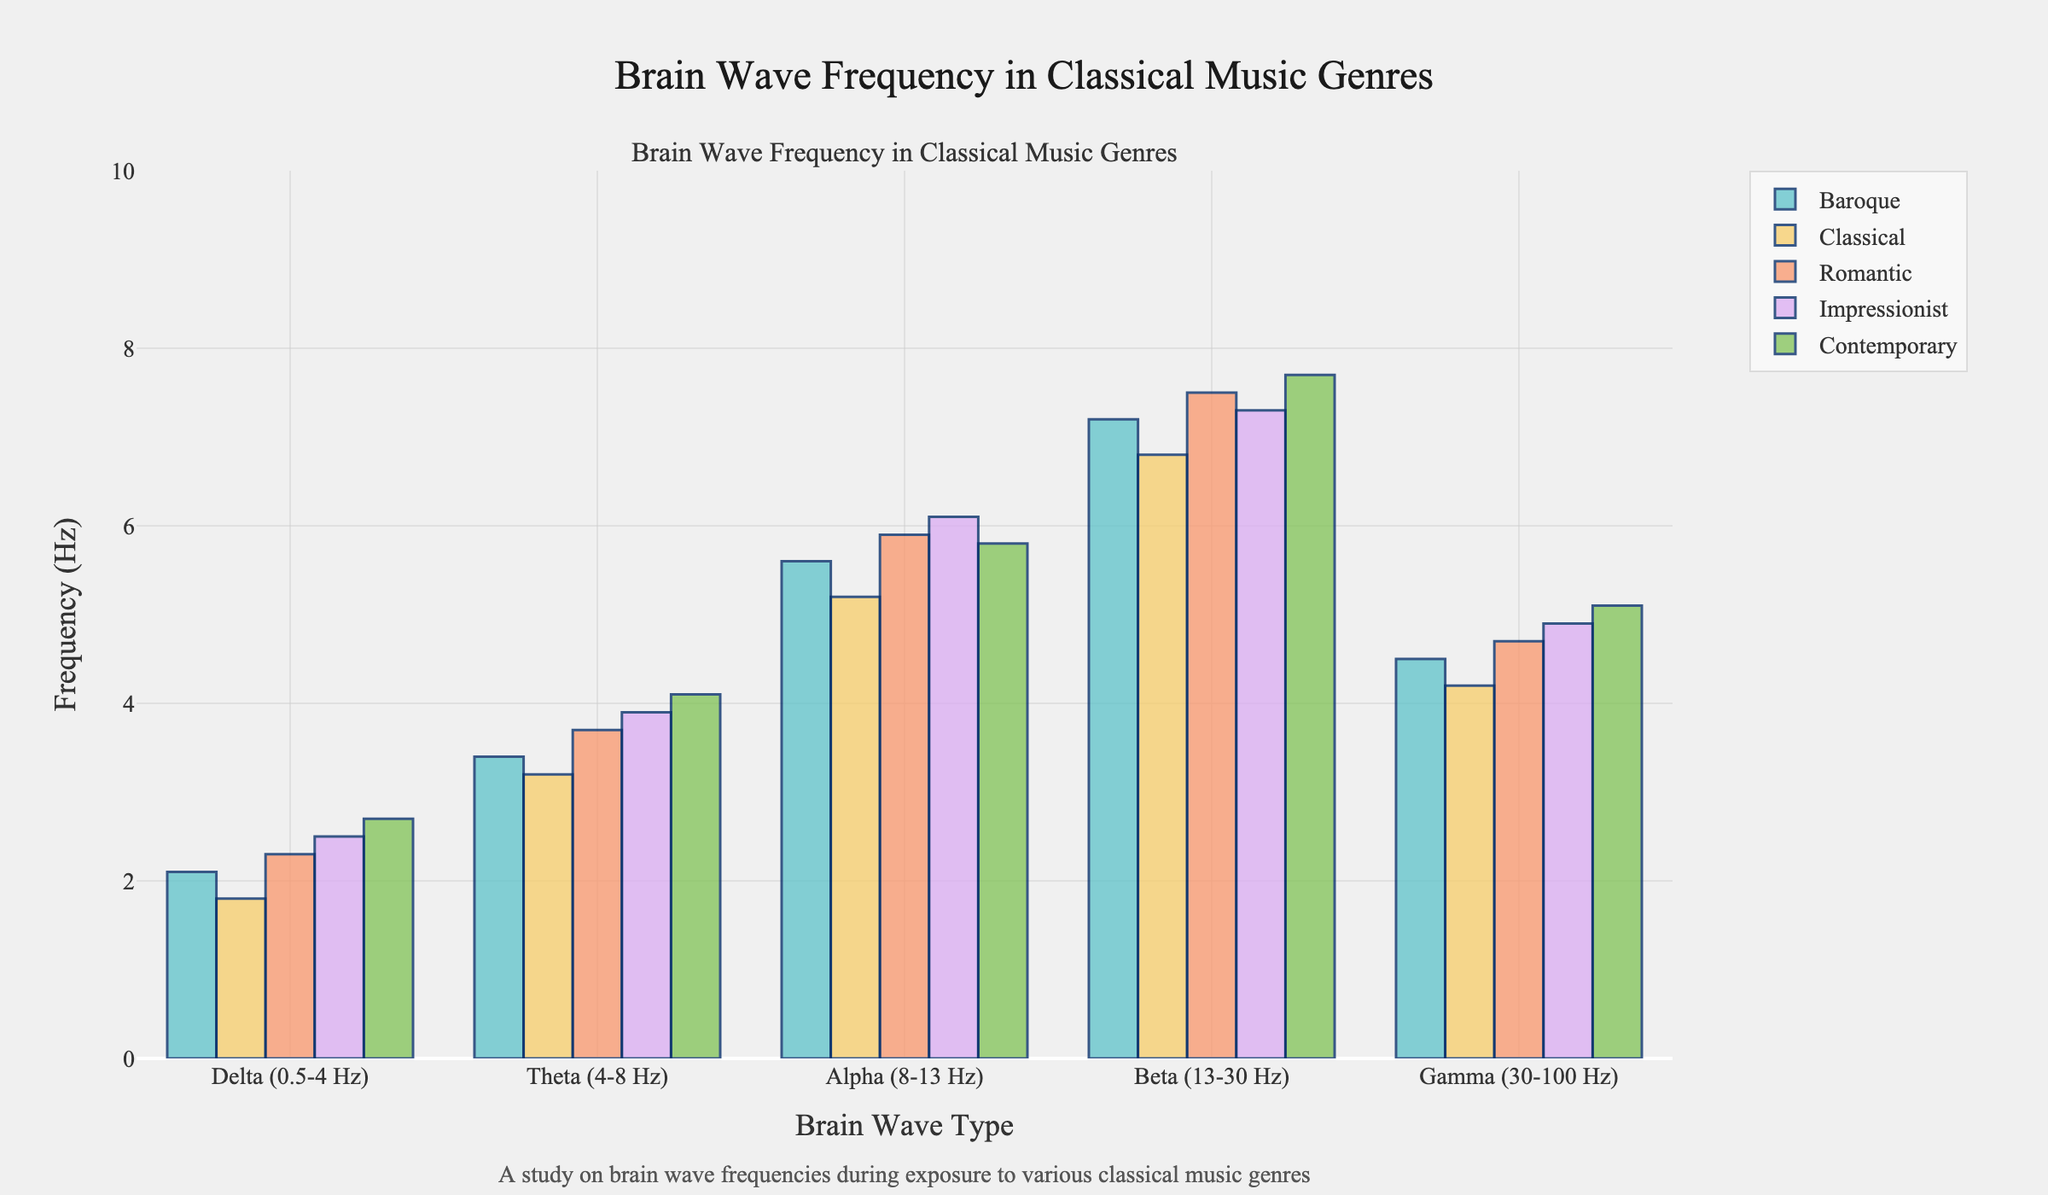What's the frequency of Delta waves for the Baroque genre? Look at the height of the bar representing Delta waves for the Baroque genre. It's marked as 2.1 Hz.
Answer: 2.1 Hz Which genre shows the highest frequency for Beta waves? Compare the heights of all bars that represent Beta waves across all genres. The Contemporary genre has the tallest bar, indicating the highest frequency.
Answer: Contemporary How much higher is the frequency of Alpha waves for Impressionist music compared to Classical music? Subtract the frequency of Alpha waves for Classical music (5.2 Hz) from that for Impressionist music (6.1 Hz): 6.1 - 5.2 = 0.9 Hz.
Answer: 0.9 Hz What is the average frequency of Theta waves across all genres? Sum the frequencies of Theta waves for all genres and divide by the number of genres: (3.4 + 3.2 + 3.7 + 3.9 + 4.1) / 5 = 3.66 Hz.
Answer: 3.66 Hz Which genre has the lowest Gamma wave frequency? Compare the heights of all bars that represent Gamma waves across all genres. The Classical genre has the lowest bar, indicating the lowest frequency.
Answer: Classical In which genre do Gamma waves have a frequency of 4.9 Hz? Look for the bar representing Gamma waves with the height corresponding to 4.9 Hz. It falls under the Impressionist genre.
Answer: Impressionist Calculate the total sum of Delta wave frequencies across all genres. Add the Delta wave frequencies for all genres: 2.1 + 1.8 + 2.3 + 2.5 + 2.7 = 11.4 Hz.
Answer: 11.4 Hz Which brain wave type shows the greatest increase in frequency from the Classical to the Contemporary genre? Calculate and compare the differences for each brain wave type: Delta (2.7-1.8 = 0.9), Theta (4.1-3.2 = 0.9), Alpha (5.8-5.2 = 0.6), Beta (7.7-6.8 = 0.9), Gamma (5.1-4.2 = 0.9). Since all show an increase of 0.9 Hz, the Delta, Theta, Beta, and Gamma waves show the greatest increase.
Answer: Delta, Theta, Beta, Gamma What is the frequency difference between Delta and Gamma waves for the Baroque genre? Subtract the Delta wave frequency from the Gamma wave frequency for the Baroque genre: 4.5 - 2.1 = 2.4 Hz.
Answer: 2.4 Hz Which brain wave type consistently shows the highest frequency across all genres? Compare the highest frequency across all brain wave types for each genre. The Beta waves have the highest frequency in every genre.
Answer: Beta 